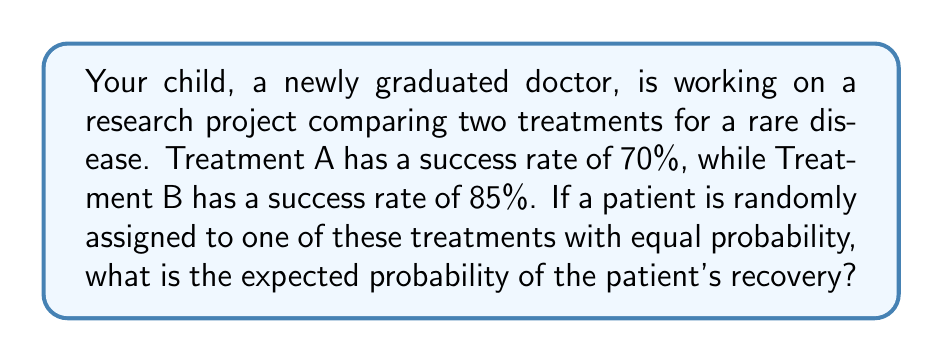Teach me how to tackle this problem. Let's approach this step-by-step:

1) First, we need to understand what "expected probability" means in this context. It's the average probability of recovery, considering both treatments.

2) We can use the law of total probability to calculate this:

   $P(\text{Recovery}) = P(\text{Recovery|A}) \cdot P(A) + P(\text{Recovery|B}) \cdot P(B)$

   Where:
   - $P(\text{Recovery|A})$ is the probability of recovery given Treatment A
   - $P(A)$ is the probability of being assigned Treatment A
   - $P(\text{Recovery|B})$ is the probability of recovery given Treatment B
   - $P(B)$ is the probability of being assigned Treatment B

3) We know:
   - $P(\text{Recovery|A}) = 0.70$ (70% success rate for Treatment A)
   - $P(\text{Recovery|B}) = 0.85$ (85% success rate for Treatment B)
   - $P(A) = P(B) = 0.5$ (equal probability of being assigned to each treatment)

4) Let's substitute these values into our equation:

   $P(\text{Recovery}) = 0.70 \cdot 0.5 + 0.85 \cdot 0.5$

5) Now we can calculate:

   $P(\text{Recovery}) = 0.35 + 0.425 = 0.775$

6) Therefore, the expected probability of the patient's recovery is 0.775 or 77.5%.
Answer: 0.775 or 77.5% 